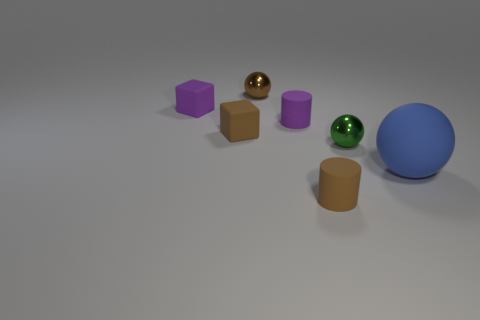What number of objects are tiny brown balls or tiny cylinders that are behind the brown rubber cylinder?
Offer a terse response. 2. Does the metal thing that is behind the small green metal object have the same size as the brown object on the right side of the brown metallic sphere?
Your answer should be very brief. Yes. What number of tiny green objects have the same shape as the big blue rubber thing?
Your answer should be very brief. 1. What shape is the thing that is the same material as the brown ball?
Your answer should be very brief. Sphere. There is a small ball that is right of the small metallic sphere left of the small brown rubber object that is in front of the blue matte object; what is its material?
Provide a short and direct response. Metal. Does the brown rubber cube have the same size as the metal thing that is in front of the purple cube?
Offer a very short reply. Yes. There is a small green thing that is the same shape as the big rubber thing; what material is it?
Offer a very short reply. Metal. What size is the matte cylinder in front of the blue sphere that is behind the brown object that is in front of the small green thing?
Provide a short and direct response. Small. Do the blue thing and the purple block have the same size?
Ensure brevity in your answer.  No. What is the material of the tiny sphere to the left of the brown object that is in front of the big blue sphere?
Your answer should be compact. Metal. 